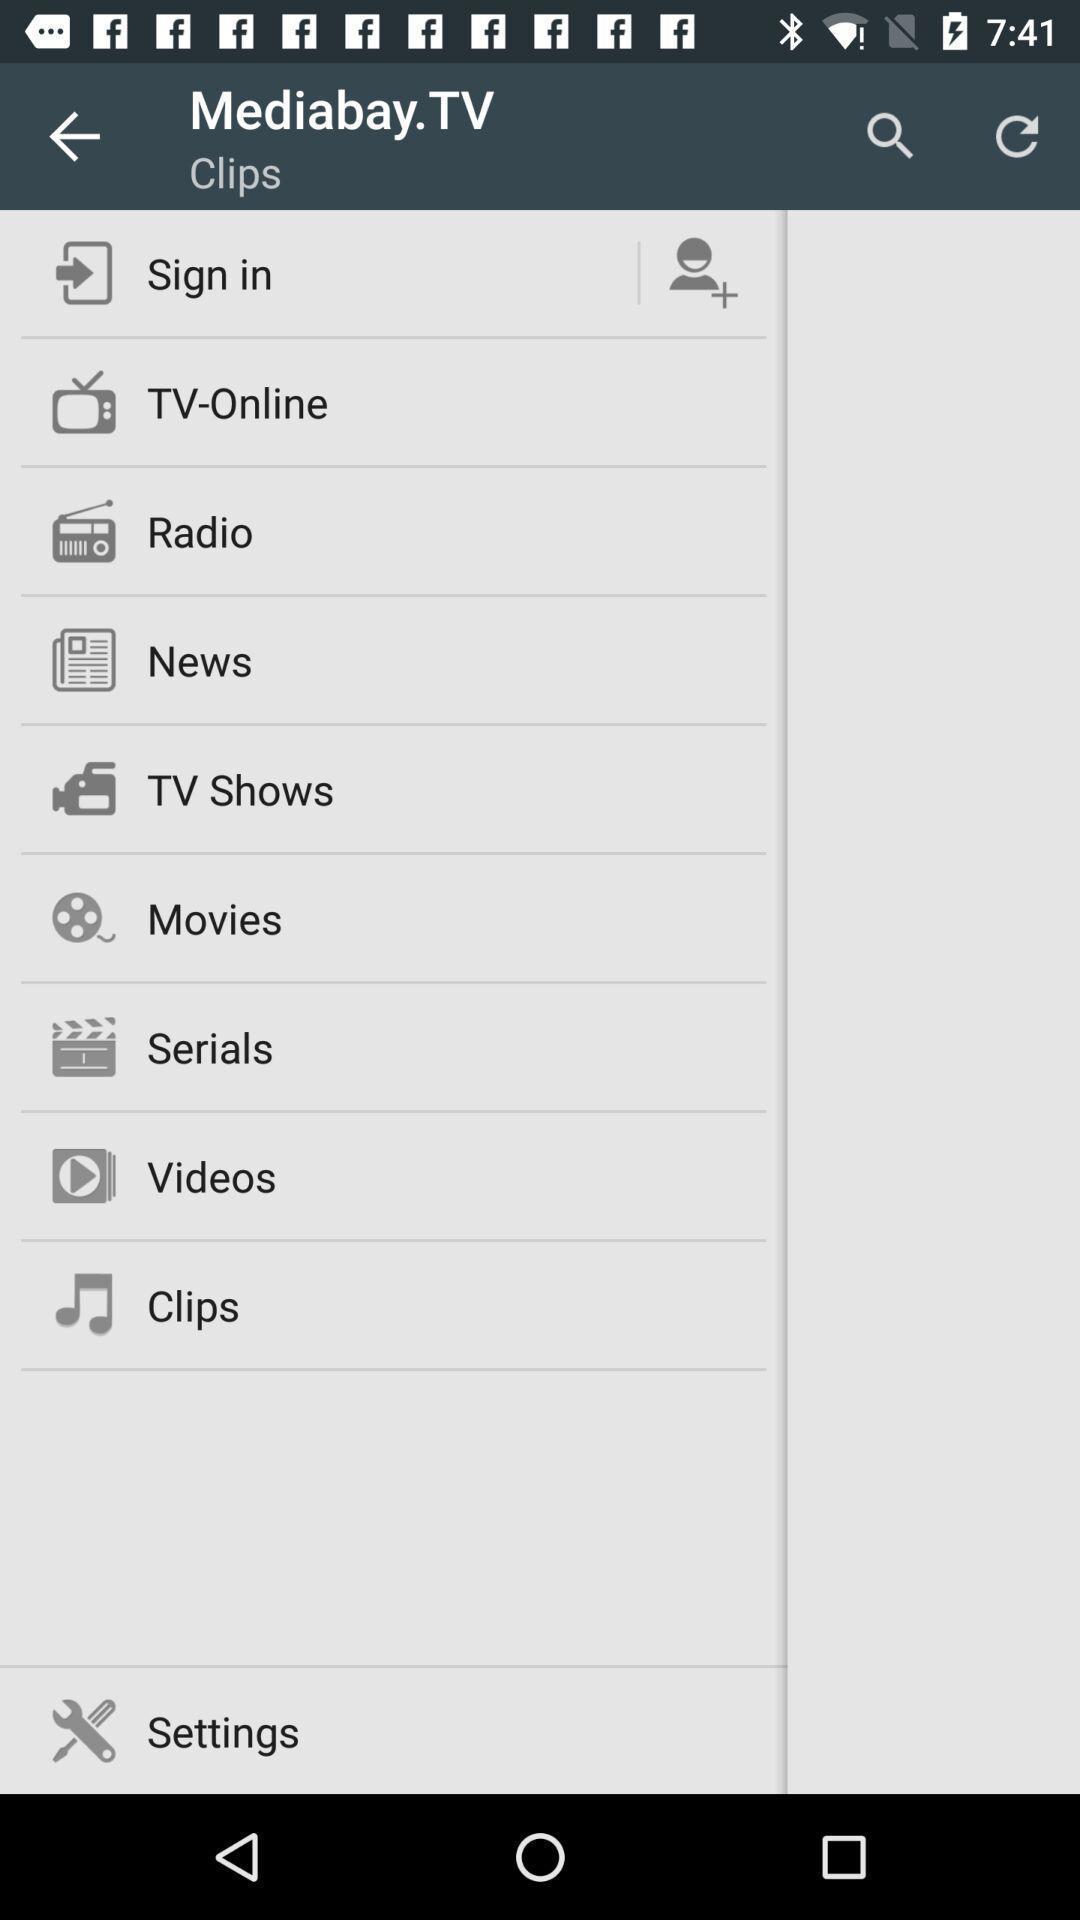What can you discern from this picture? Screen shows about sign in details. 